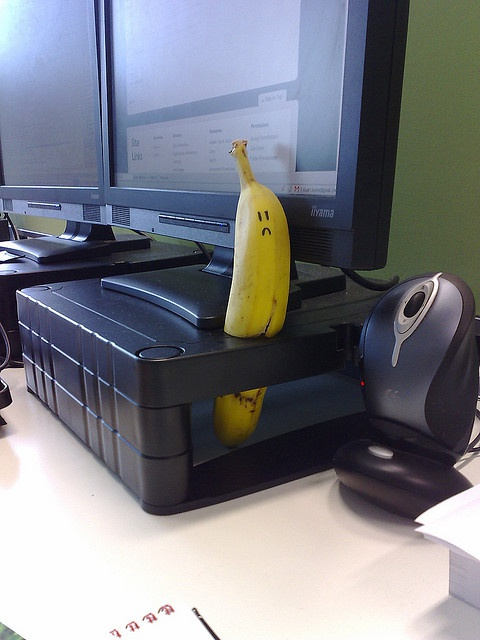Describe the objects in this image and their specific colors. I can see tv in white, darkgray, black, and gray tones, tv in white, gray, darkgray, and lavender tones, mouse in white, black, gray, and darkgray tones, banana in white, olive, and tan tones, and mouse in white, black, and gray tones in this image. 